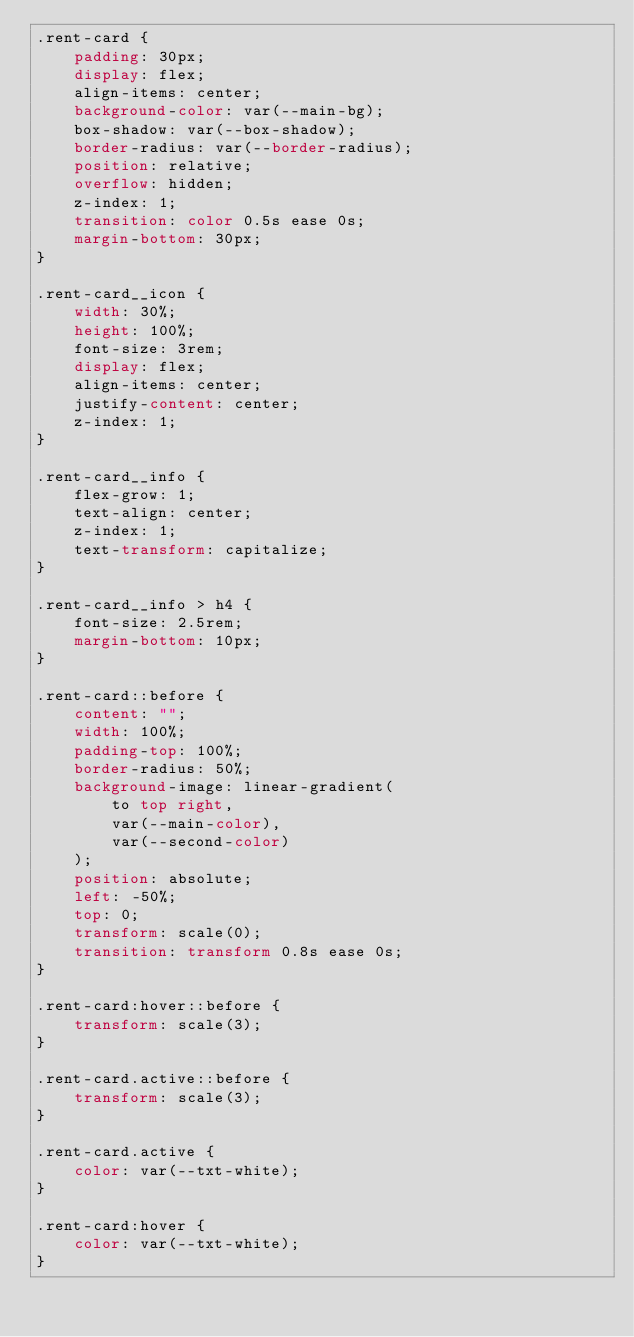<code> <loc_0><loc_0><loc_500><loc_500><_CSS_>.rent-card {
    padding: 30px;
    display: flex;
    align-items: center;
    background-color: var(--main-bg);
    box-shadow: var(--box-shadow);
    border-radius: var(--border-radius);
    position: relative;
    overflow: hidden;
    z-index: 1;
    transition: color 0.5s ease 0s;
    margin-bottom: 30px;
}

.rent-card__icon {
    width: 30%;
    height: 100%;
    font-size: 3rem;
    display: flex;
    align-items: center;
    justify-content: center;
    z-index: 1;
}

.rent-card__info {
    flex-grow: 1;
    text-align: center;
    z-index: 1;
    text-transform: capitalize;
}

.rent-card__info > h4 {
    font-size: 2.5rem;
    margin-bottom: 10px;
}

.rent-card::before {
    content: "";
    width: 100%;
    padding-top: 100%;
    border-radius: 50%;
    background-image: linear-gradient(
        to top right,
        var(--main-color),
        var(--second-color)
    );
    position: absolute;
    left: -50%;
    top: 0;
    transform: scale(0);
    transition: transform 0.8s ease 0s;
}

.rent-card:hover::before {
    transform: scale(3);
}

.rent-card.active::before {
    transform: scale(3);
}

.rent-card.active {
    color: var(--txt-white);
}

.rent-card:hover {
    color: var(--txt-white);
}
</code> 